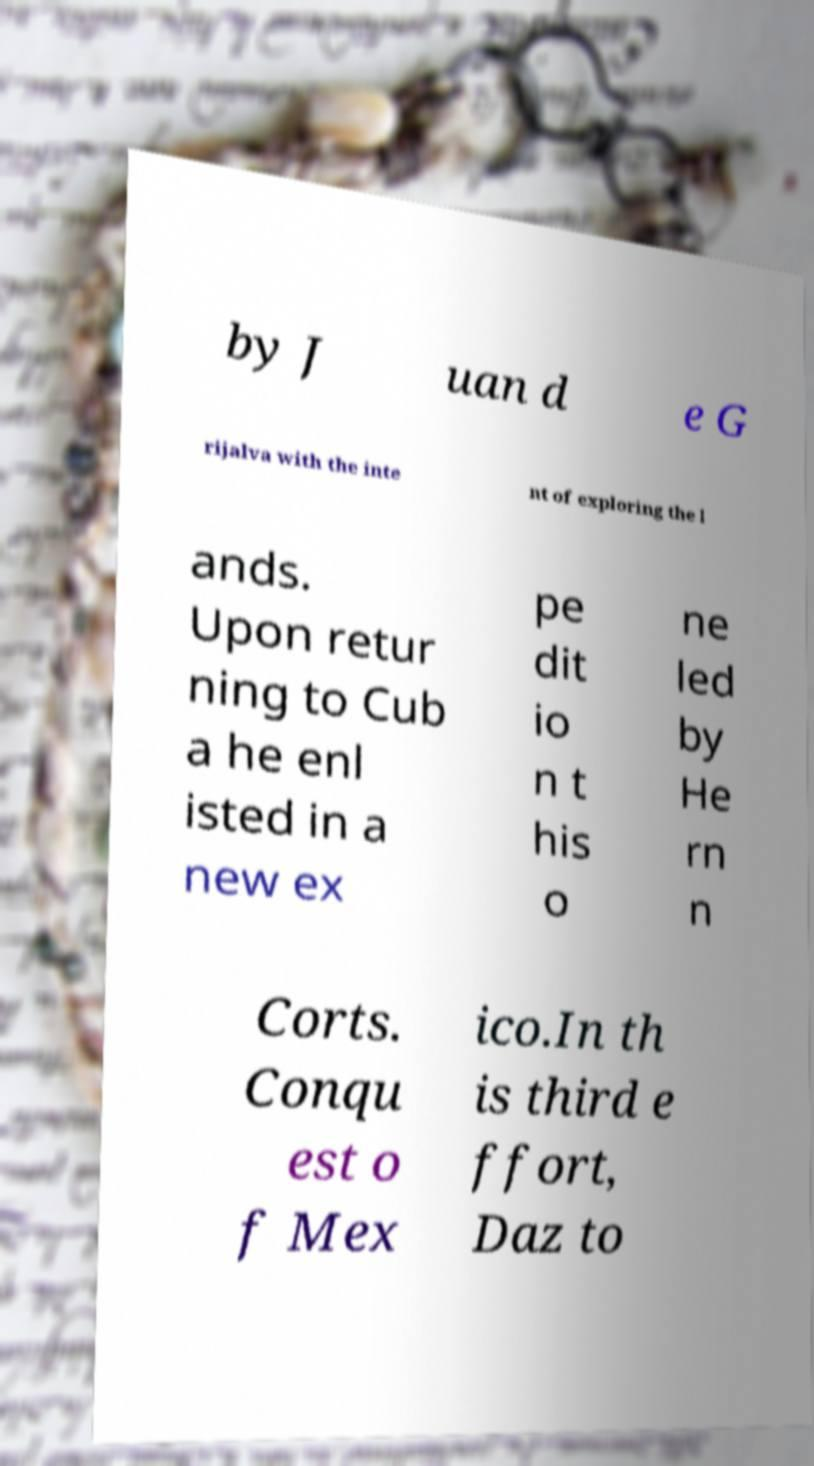Can you accurately transcribe the text from the provided image for me? by J uan d e G rijalva with the inte nt of exploring the l ands. Upon retur ning to Cub a he enl isted in a new ex pe dit io n t his o ne led by He rn n Corts. Conqu est o f Mex ico.In th is third e ffort, Daz to 